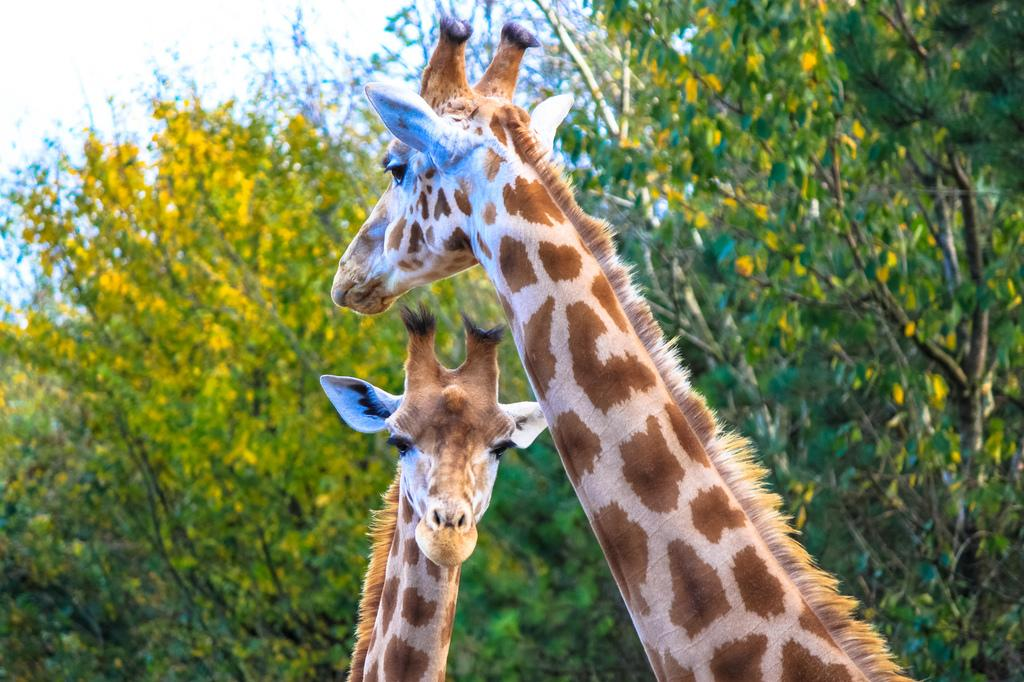How many giraffes are in the image? There are two giraffes in the image. What type of vegetation is present in the image? There are trees in the image. What is visible at the top of the image? The sky is visible at the top of the image. What type of rake is being used by the giraffes in the image? There is no rake present in the image; the giraffes are not using any tools. 